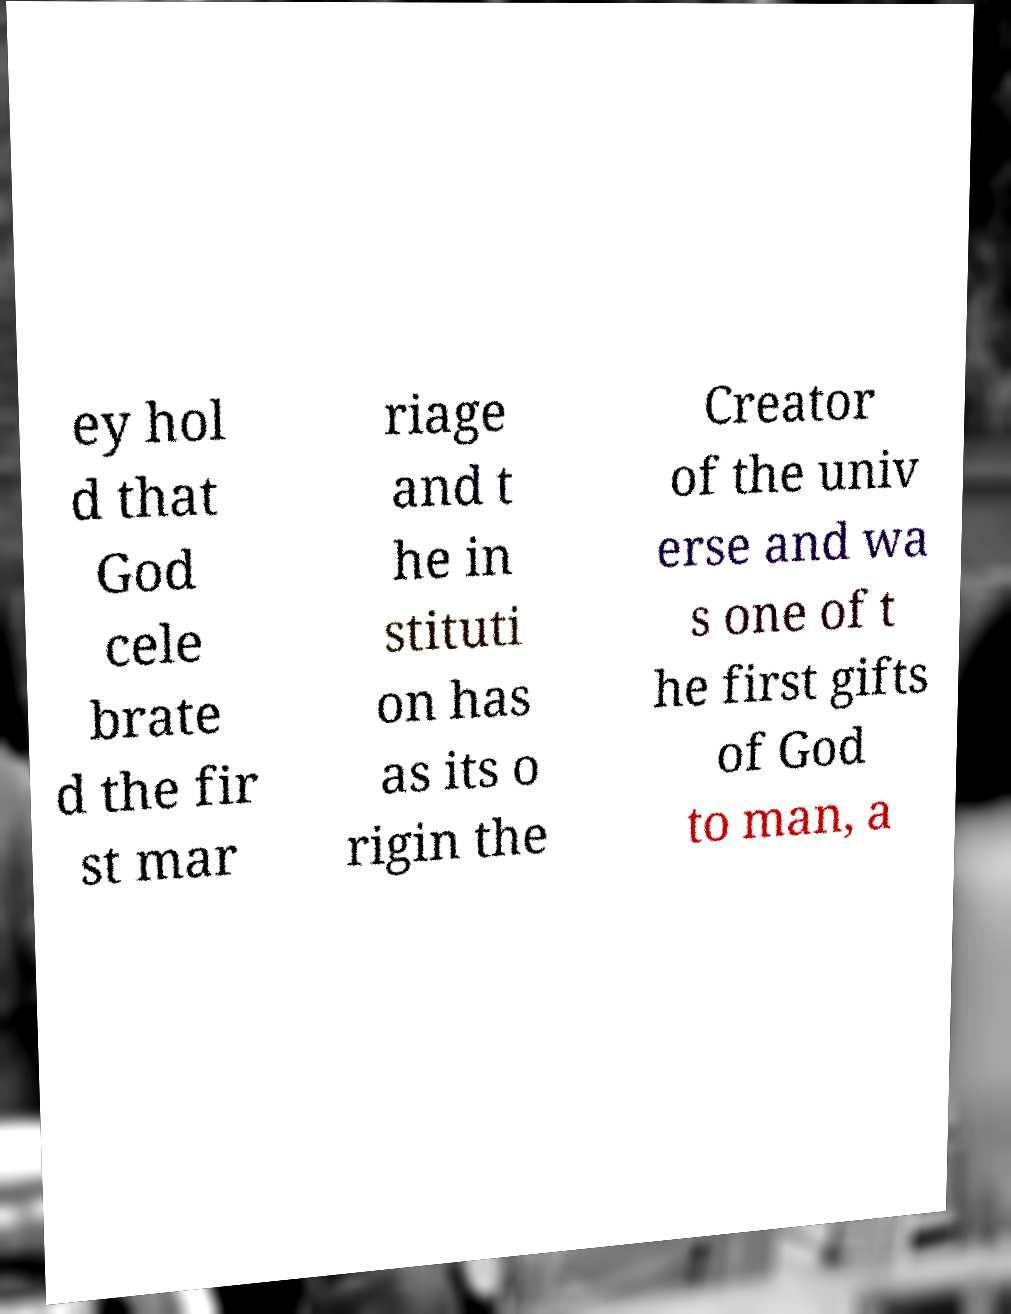I need the written content from this picture converted into text. Can you do that? ey hol d that God cele brate d the fir st mar riage and t he in stituti on has as its o rigin the Creator of the univ erse and wa s one of t he first gifts of God to man, a 